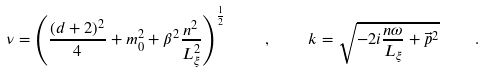Convert formula to latex. <formula><loc_0><loc_0><loc_500><loc_500>\nu = \left ( \frac { ( d + 2 ) ^ { 2 } } { 4 } + m _ { 0 } ^ { 2 } + \beta ^ { 2 } \frac { n ^ { 2 } } { L ^ { 2 } _ { \xi } } \right ) ^ { \frac { 1 } { 2 } } \quad , \quad k = \sqrt { - 2 i \frac { n \omega } { L _ { \xi } } + \vec { p } ^ { 2 } } \quad .</formula> 